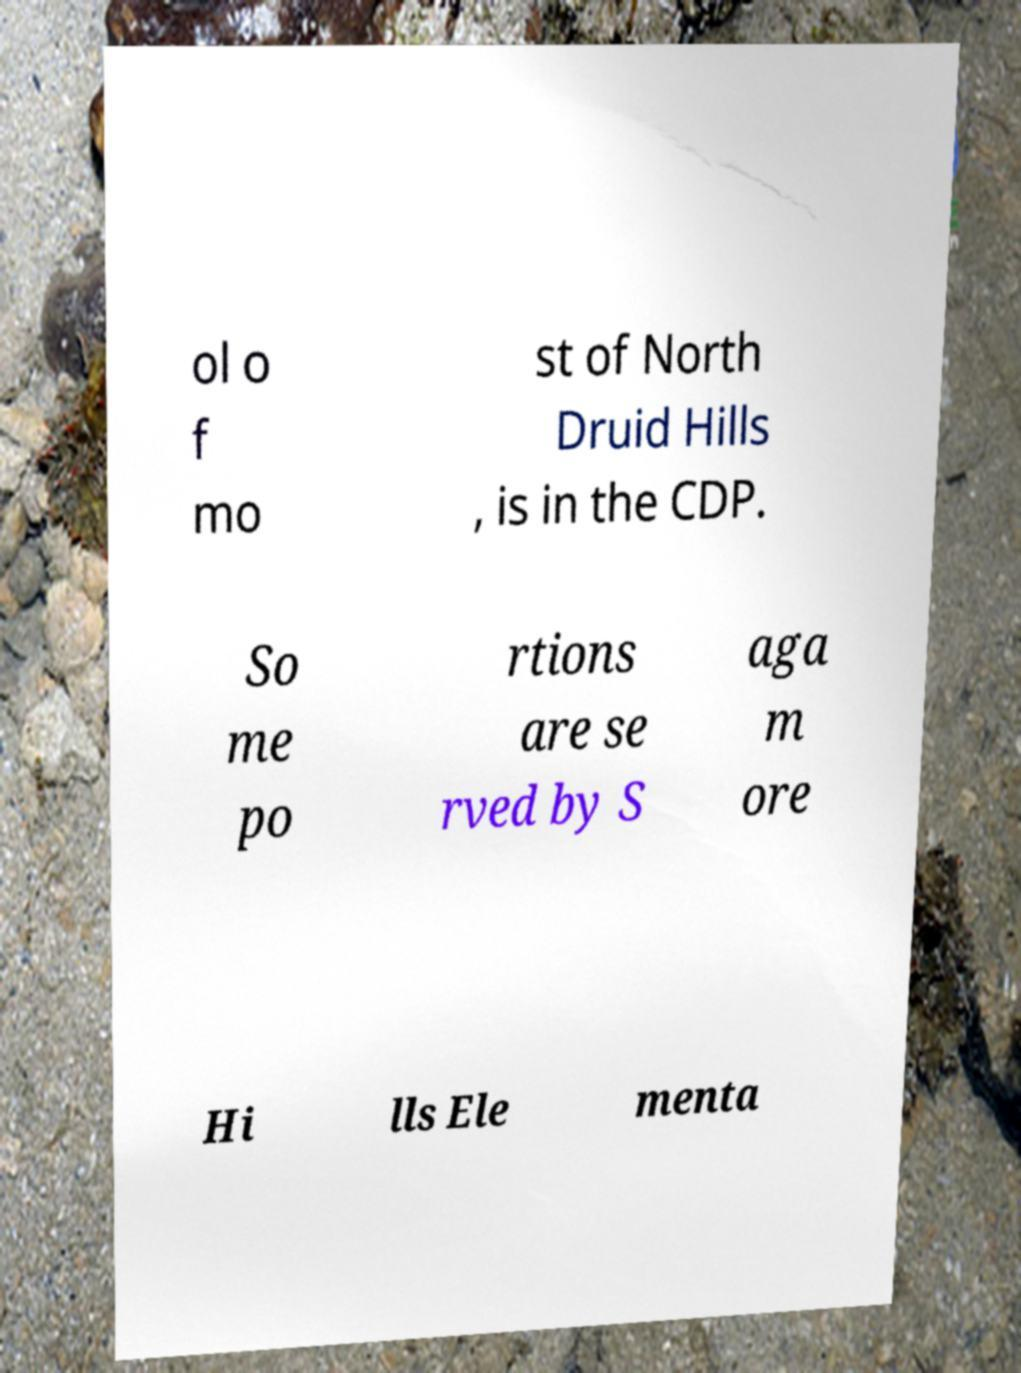Please identify and transcribe the text found in this image. ol o f mo st of North Druid Hills , is in the CDP. So me po rtions are se rved by S aga m ore Hi lls Ele menta 